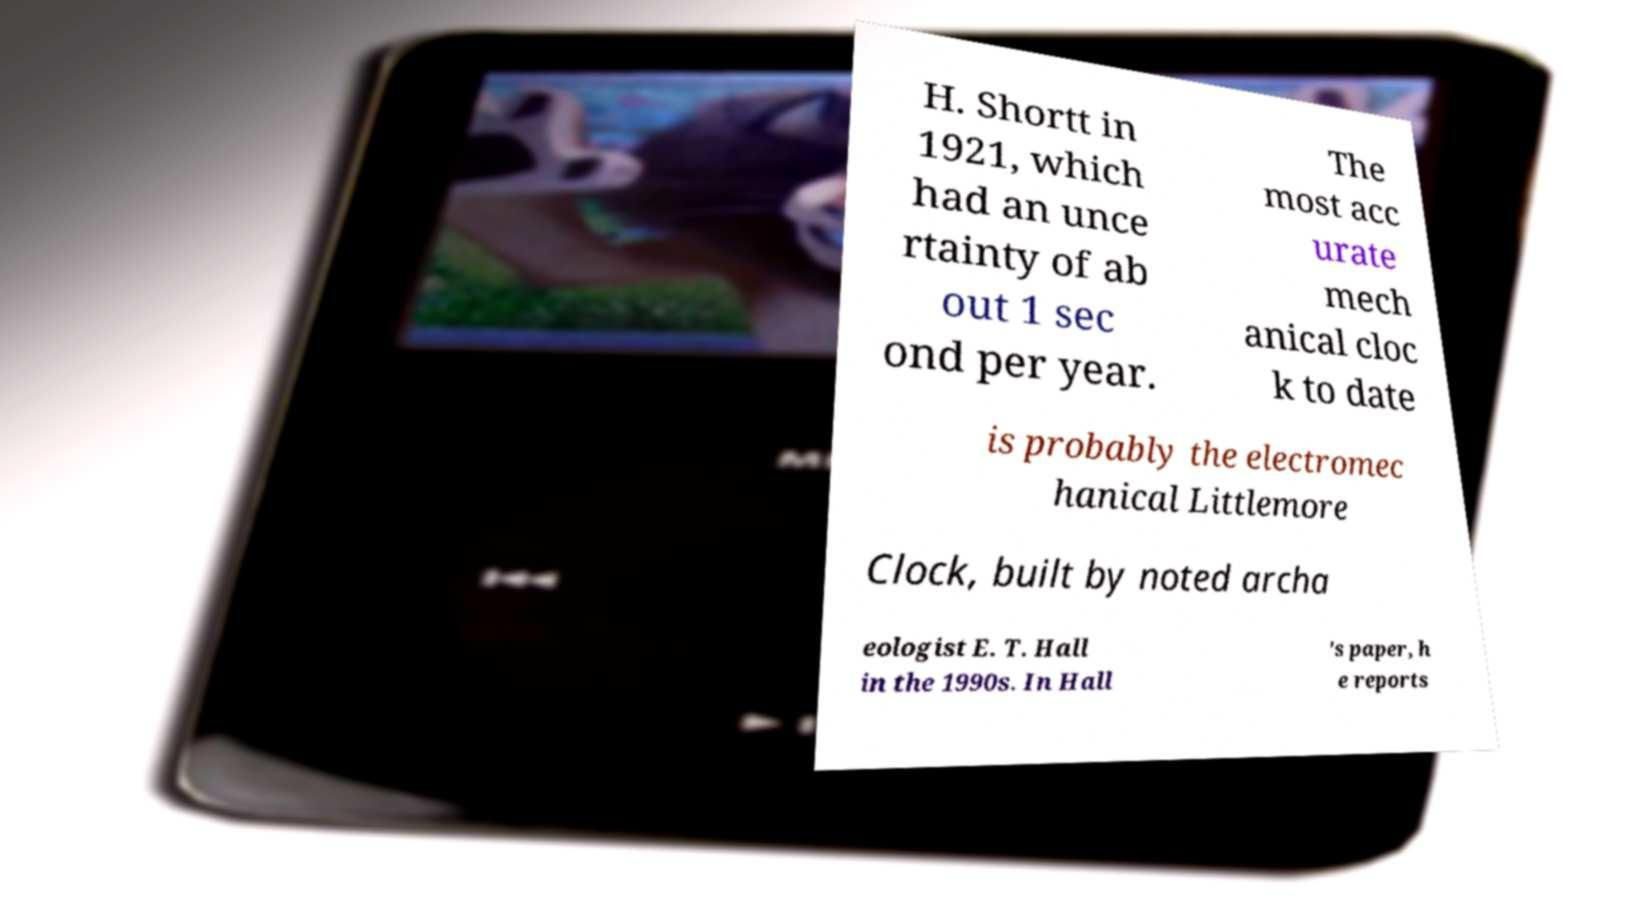There's text embedded in this image that I need extracted. Can you transcribe it verbatim? H. Shortt in 1921, which had an unce rtainty of ab out 1 sec ond per year. The most acc urate mech anical cloc k to date is probably the electromec hanical Littlemore Clock, built by noted archa eologist E. T. Hall in the 1990s. In Hall 's paper, h e reports 